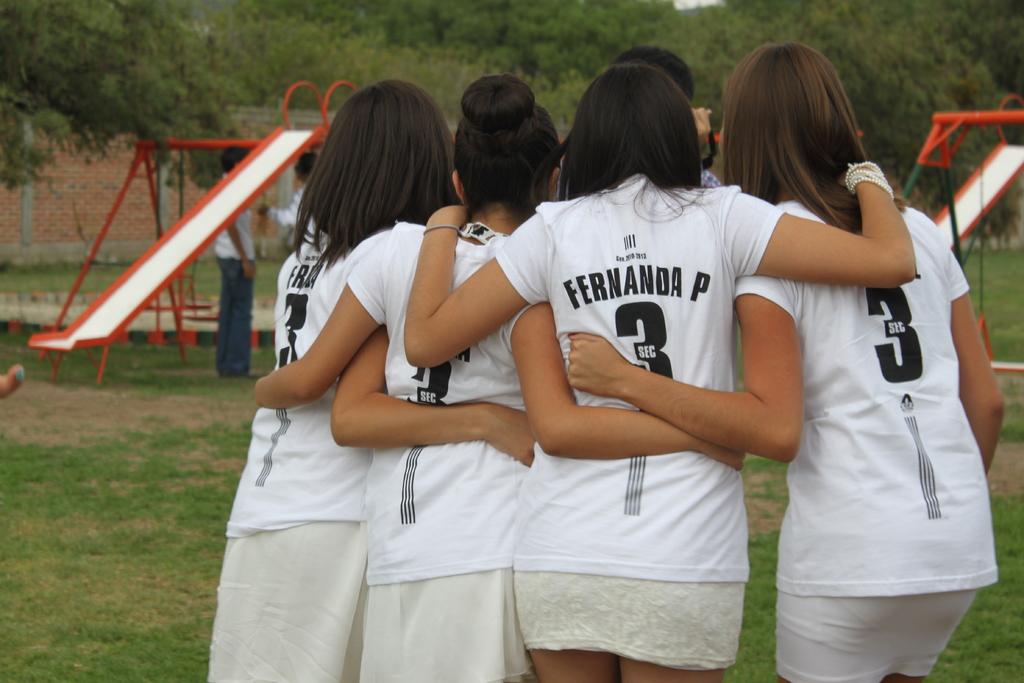What number do they all have on the back of their shirts?
Give a very brief answer. 3. 